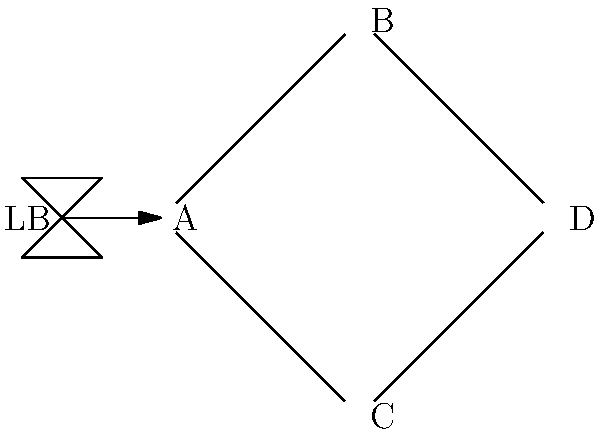Given the network topology diagram above, where LB represents a load balancer and A, B, C, and D represent servers, which configuration change would most likely improve the load balancing efficiency? To improve load balancing efficiency, we need to consider the following steps:

1. Analyze the current topology:
   - The load balancer (LB) is directly connected to server A.
   - Servers B and C are connected to A.
   - Servers B and C are both connected to D.

2. Identify the bottleneck:
   - All traffic must pass through server A, creating a potential single point of failure and bottleneck.

3. Consider load balancing principles:
   - Distribute traffic evenly across all available servers.
   - Minimize network hops for better performance.

4. Propose improvements:
   - Connect the load balancer directly to all front-end servers (A, B, and C).
   - This allows for direct distribution of traffic to multiple servers.

5. Benefits of the proposed change:
   - Reduces load on server A.
   - Improves fault tolerance by eliminating the single point of failure.
   - Decreases network latency by reducing the number of hops for some requests.
   - Allows for more efficient use of all available server resources.

Therefore, the most effective configuration change to improve load balancing efficiency would be to connect the load balancer directly to servers B and C, in addition to its existing connection to server A.
Answer: Connect LB directly to servers B and C 